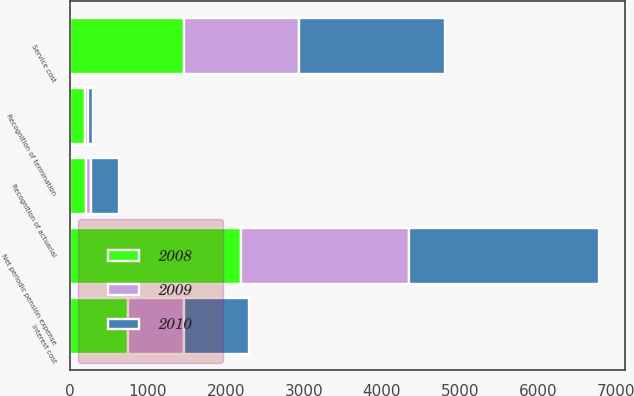Convert chart to OTSL. <chart><loc_0><loc_0><loc_500><loc_500><stacked_bar_chart><ecel><fcel>Service cost<fcel>Interest cost<fcel>Recognition of actuarial<fcel>Recognition of termination<fcel>Net periodic pension expense<nl><fcel>2010<fcel>1875<fcel>840<fcel>350<fcel>65<fcel>2430<nl><fcel>2008<fcel>1465<fcel>742<fcel>200<fcel>192<fcel>2199<nl><fcel>2009<fcel>1470<fcel>717<fcel>74<fcel>40<fcel>2153<nl></chart> 